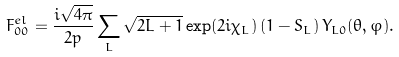Convert formula to latex. <formula><loc_0><loc_0><loc_500><loc_500>F _ { 0 0 } ^ { e l } = \frac { i \sqrt { 4 \pi } } { 2 p } \sum _ { L } \sqrt { 2 L + 1 } \exp ( 2 i \chi _ { L } ) \left ( 1 - S _ { L } \right ) Y _ { L 0 } ( \theta , \varphi ) .</formula> 